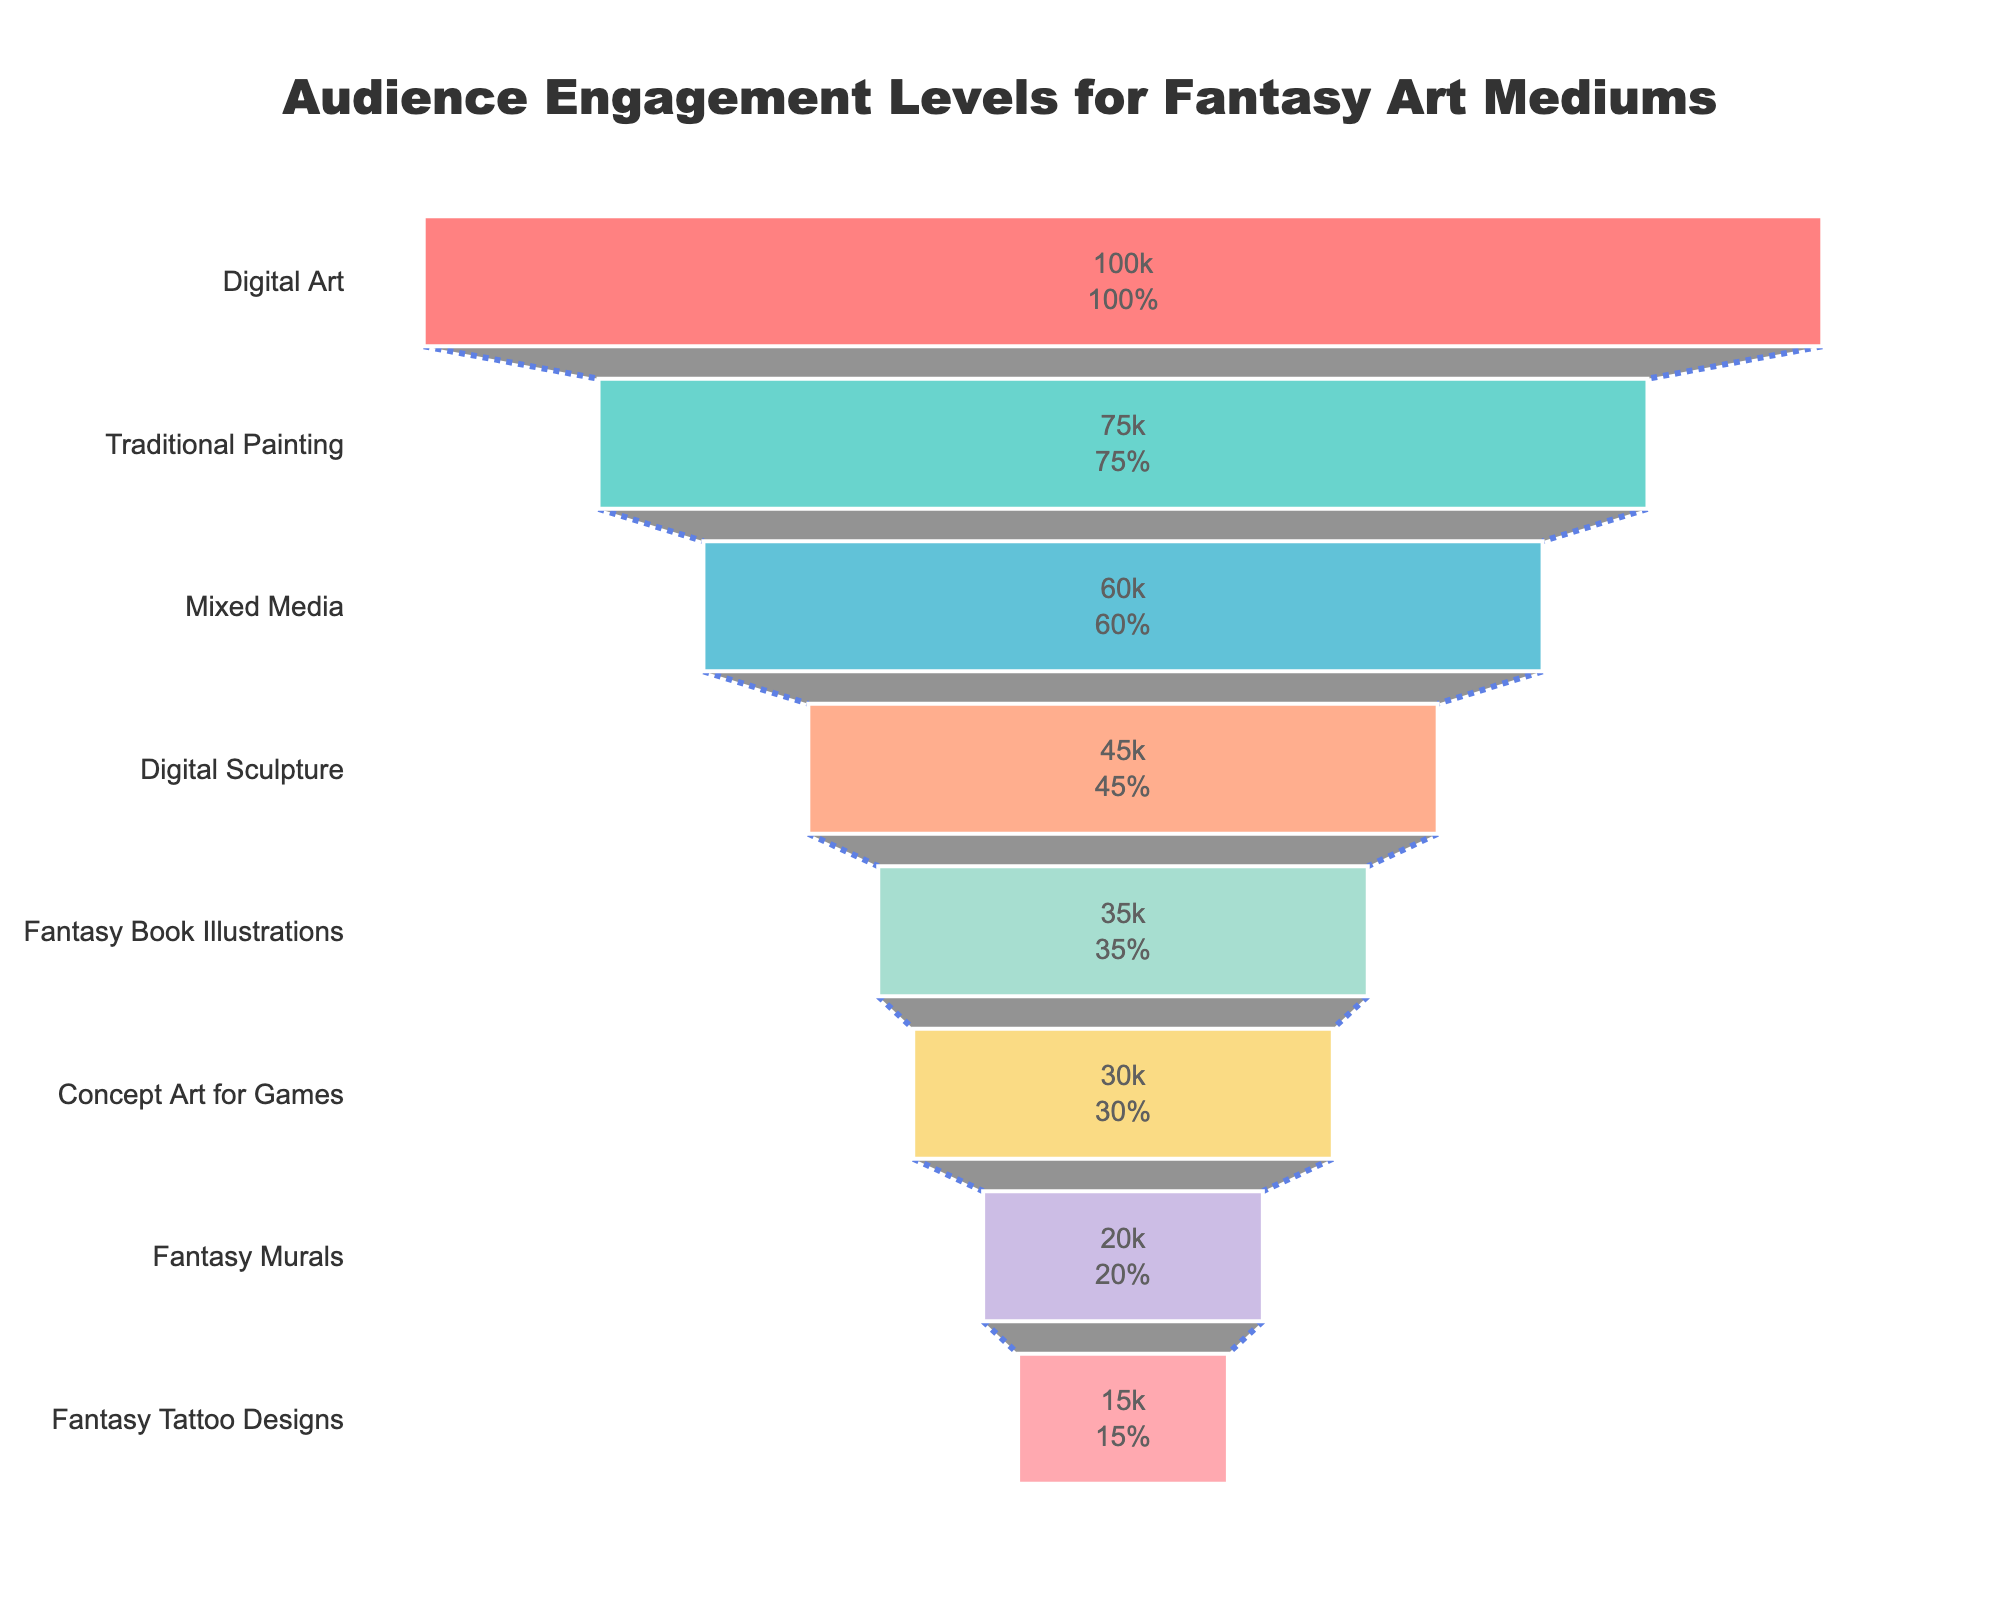what is the title of the chart? The title is located at the top of the chart and provides a description of what the chart is about. The title reads "Audience Engagement Levels for Fantasy Art Mediums".
Answer: Audience Engagement Levels for Fantasy Art Mediums Which medium has the highest audience engagement? Among all the data points represented in the funnel chart, the topmost segment denotes the medium with the highest audience engagement. In this case, it is "Digital Art" with an engagement level of 100,000.
Answer: Digital Art What is the total audience engagement across all fantasy art mediums? At the bottom of the chart, below the funnel, there is an annotation that states "Total Engagement: 400,000". This gives the sum of audience engagement across all the mediums.
Answer: 400,000 How much more audience engagement does Digital Art have compared to Fantasy Tattoo Designs? To find this, we subtract the engagement level of Fantasy Tattoo Designs (15,000) from the engagement level of Digital Art (100,000). 100,000 - 15,000 = 85,000.
Answer: 85,000 What percentage of the initial audience engagement does Traditional Painting have? The funnel chart includes text information that provides the value and the percentage of the initial audience engagement for each medium. Traditional Painting has an engagement level of 75,000, which is 75% of the initial (Digital Art’s 100,000).
Answer: 75% What is the median engagement level of all the fantasy art mediums? First, list the engagement levels in ascending order: 15,000, 20,000, 30,000, 35,000, 45,000, 60,000, 75,000, 100,000. With 8 data points, the median would be the average of the 4th and 5th values: (35,000 + 45,000)/2 = 40,000.
Answer: 40,000 How does the engagement level for Fantasy Book Illustrations compare to Digital Sculpture? By comparing their values, Fantasy Book Illustrations has an engagement level of 35,000, whereas Digital Sculpture has an engagement level of 45,000. Digital Sculpture has 10,000 more engagements than Fantasy Book Illustrations.
Answer: Digital Sculpture has 10,000 more engagements Which medium has the lowest audience engagement? At the bottom of the funnel chart, the segment representing Fantasy Tattoo Designs is the smallest, indicating it has the lowest audience engagement at 15,000.
Answer: Fantasy Tattoo Designs What is the combined audience engagement of Traditional Painting and Mixed Media? Adding the engagement levels of Traditional Painting (75,000) and Mixed Media (60,000) gives 75,000 + 60,000 = 135,000.
Answer: 135,000 